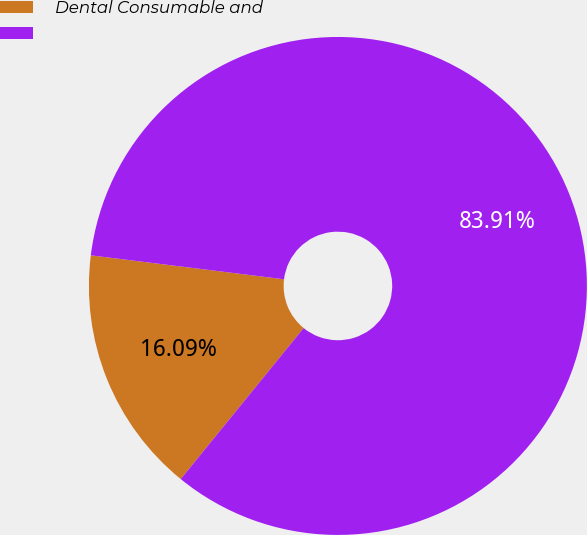<chart> <loc_0><loc_0><loc_500><loc_500><pie_chart><fcel>Dental Consumable and<fcel>Unnamed: 1<nl><fcel>16.09%<fcel>83.91%<nl></chart> 